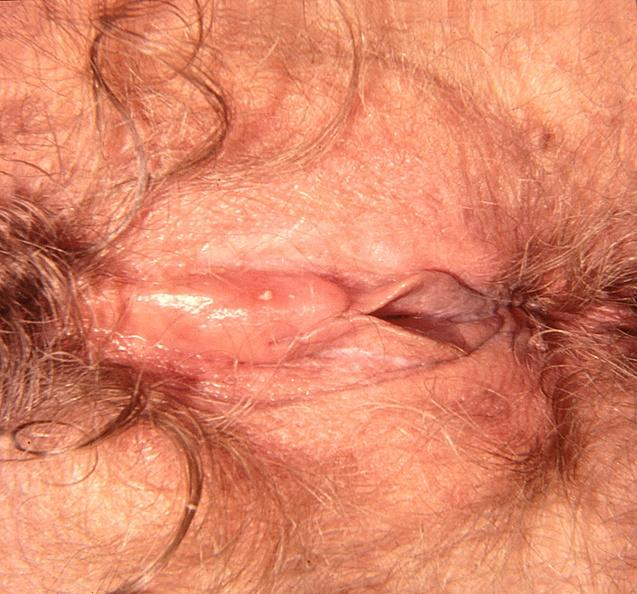does this image show vaginal herpes?
Answer the question using a single word or phrase. Yes 